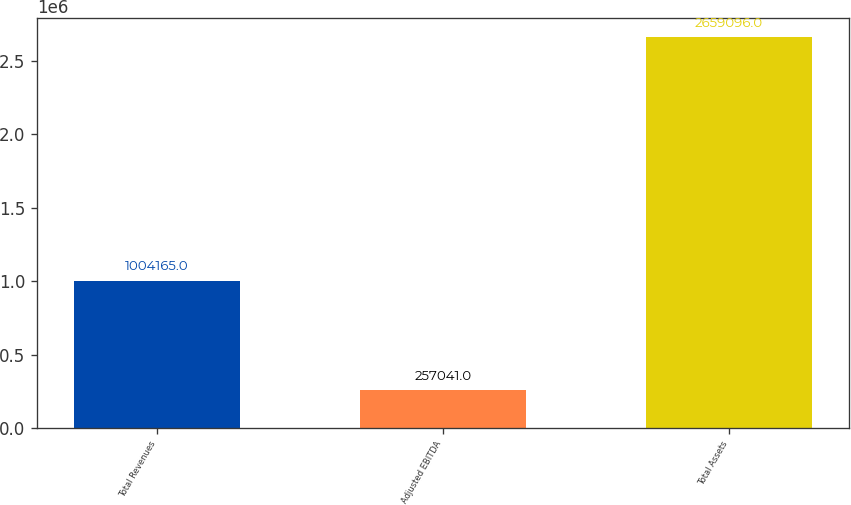Convert chart to OTSL. <chart><loc_0><loc_0><loc_500><loc_500><bar_chart><fcel>Total Revenues<fcel>Adjusted EBITDA<fcel>Total Assets<nl><fcel>1.00416e+06<fcel>257041<fcel>2.6591e+06<nl></chart> 